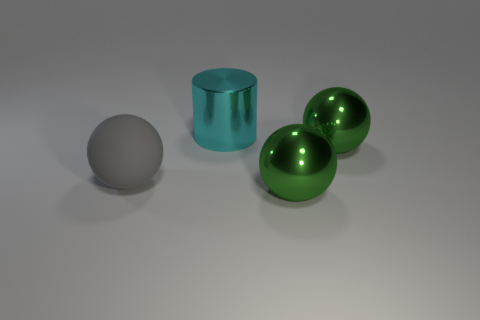Are there any other things that are the same shape as the cyan object?
Your answer should be very brief. No. How many cyan objects are big metal things or big matte balls?
Offer a terse response. 1. What is the big thing that is behind the gray thing and in front of the big metallic cylinder made of?
Your answer should be very brief. Metal. Is the large cyan cylinder made of the same material as the gray sphere?
Your answer should be very brief. No. What number of red things have the same size as the gray sphere?
Give a very brief answer. 0. Are there an equal number of big cyan shiny cylinders that are left of the rubber object and large cyan cubes?
Keep it short and to the point. Yes. How many large objects are both behind the matte ball and to the right of the big metal cylinder?
Your answer should be very brief. 1. There is a green metallic thing that is in front of the large gray thing; does it have the same shape as the gray matte thing?
Keep it short and to the point. Yes. What is the material of the cylinder that is the same size as the gray matte object?
Ensure brevity in your answer.  Metal. Are there the same number of cyan cylinders to the left of the cyan cylinder and cyan shiny cylinders that are behind the big gray thing?
Your response must be concise. No. 